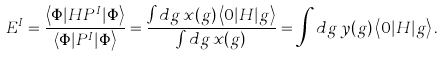<formula> <loc_0><loc_0><loc_500><loc_500>E ^ { I } = \frac { \left \langle \Phi | H P ^ { I } | \Phi \right \rangle } { \left \langle \Phi | P ^ { I } | \Phi \right \rangle } = \frac { \int d g \, x ( g ) \left \langle 0 | H | g \right \rangle } { \int d g \, x ( g ) } = \int d g \, y ( g ) \left \langle 0 | H | g \right \rangle .</formula> 